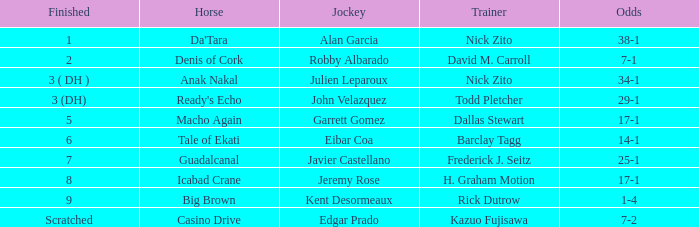What are the Odds for Trainer Barclay Tagg? 14-1. 